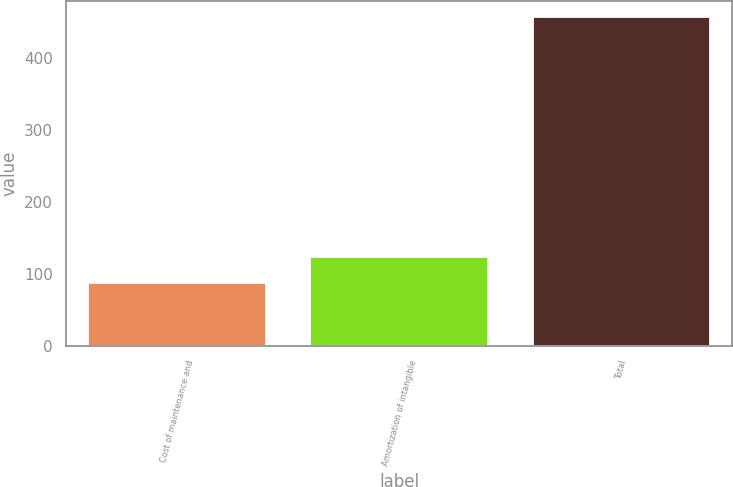<chart> <loc_0><loc_0><loc_500><loc_500><bar_chart><fcel>Cost of maintenance and<fcel>Amortization of intangible<fcel>Total<nl><fcel>87.2<fcel>124.17<fcel>456.9<nl></chart> 